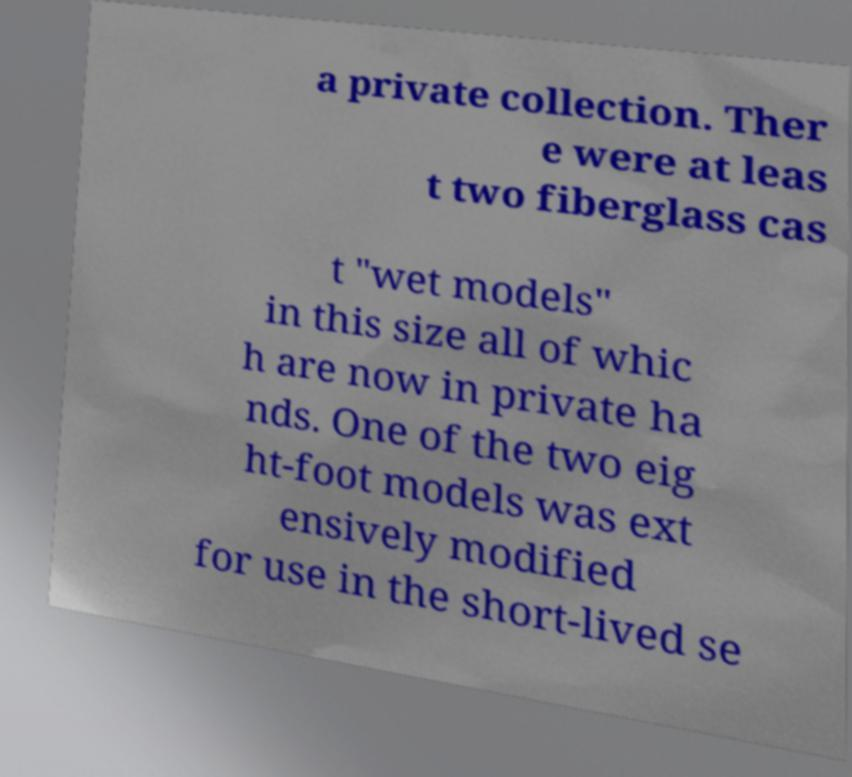For documentation purposes, I need the text within this image transcribed. Could you provide that? a private collection. Ther e were at leas t two fiberglass cas t "wet models" in this size all of whic h are now in private ha nds. One of the two eig ht-foot models was ext ensively modified for use in the short-lived se 